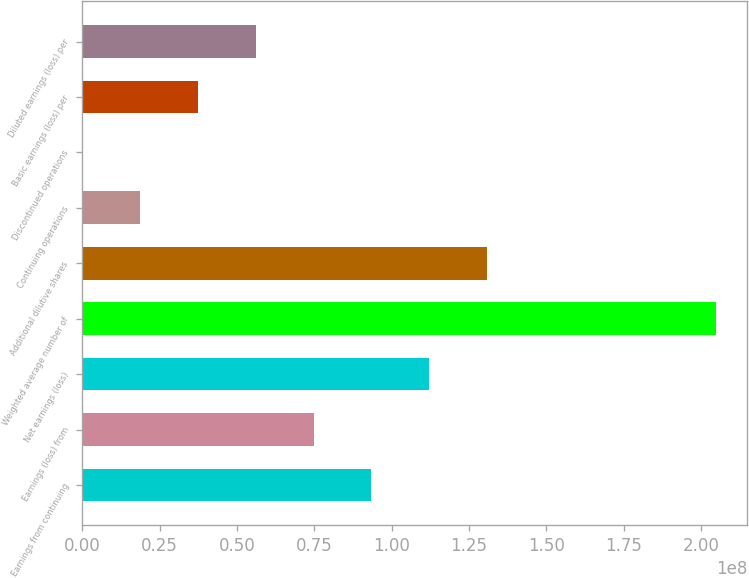Convert chart. <chart><loc_0><loc_0><loc_500><loc_500><bar_chart><fcel>Earnings from continuing<fcel>Earnings (loss) from<fcel>Net earnings (loss)<fcel>Weighted average number of<fcel>Additional dilutive shares<fcel>Continuing operations<fcel>Discontinued operations<fcel>Basic earnings (loss) per<fcel>Diluted earnings (loss) per<nl><fcel>9.34164e+07<fcel>7.47331e+07<fcel>1.121e+08<fcel>2.04737e+08<fcel>1.30783e+08<fcel>1.86833e+07<fcel>0.35<fcel>3.73665e+07<fcel>5.60498e+07<nl></chart> 